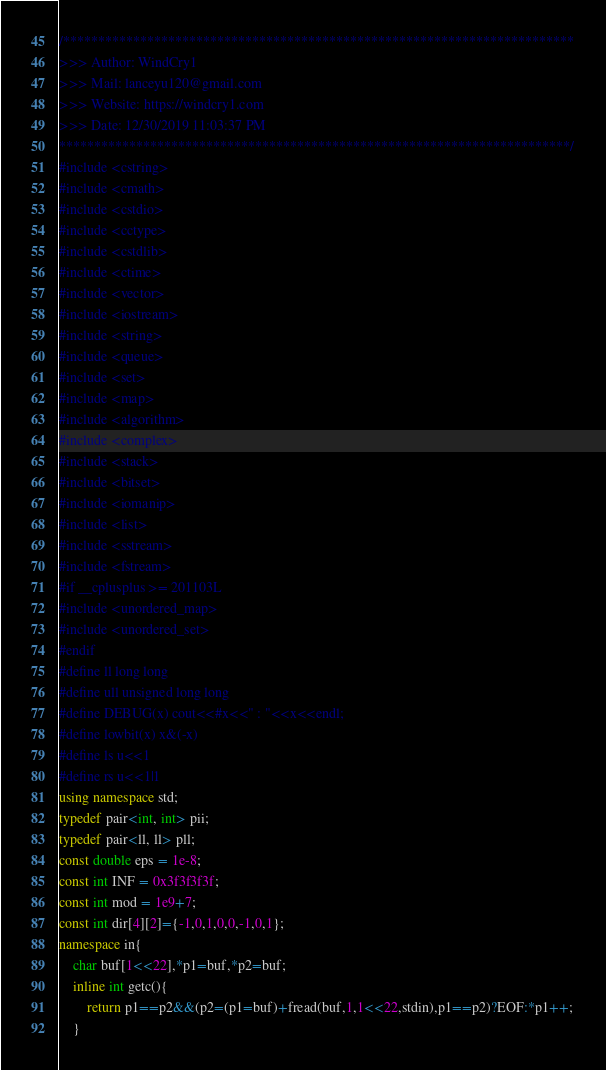Convert code to text. <code><loc_0><loc_0><loc_500><loc_500><_C++_>/*************************************************************************
>>> Author: WindCry1
>>> Mail: lanceyu120@gmail.com
>>> Website: https://windcry1.com
>>> Date: 12/30/2019 11:03:37 PM
*************************************************************************/
#include <cstring>
#include <cmath>
#include <cstdio>
#include <cctype>
#include <cstdlib>
#include <ctime>
#include <vector>
#include <iostream>
#include <string>
#include <queue>
#include <set>
#include <map>
#include <algorithm>
#include <complex>
#include <stack>
#include <bitset>
#include <iomanip>
#include <list>
#include <sstream>
#include <fstream>
#if __cplusplus >= 201103L
#include <unordered_map>
#include <unordered_set>
#endif
#define ll long long
#define ull unsigned long long
#define DEBUG(x) cout<<#x<<" : "<<x<<endl;
#define lowbit(x) x&(-x)
#define ls u<<1
#define rs u<<1|1
using namespace std;
typedef pair<int, int> pii;
typedef pair<ll, ll> pll;
const double eps = 1e-8;
const int INF = 0x3f3f3f3f;
const int mod = 1e9+7;
const int dir[4][2]={-1,0,1,0,0,-1,0,1};
namespace in{
	char buf[1<<22],*p1=buf,*p2=buf;
	inline int getc(){
		return p1==p2&&(p2=(p1=buf)+fread(buf,1,1<<22,stdin),p1==p2)?EOF:*p1++;
	}</code> 